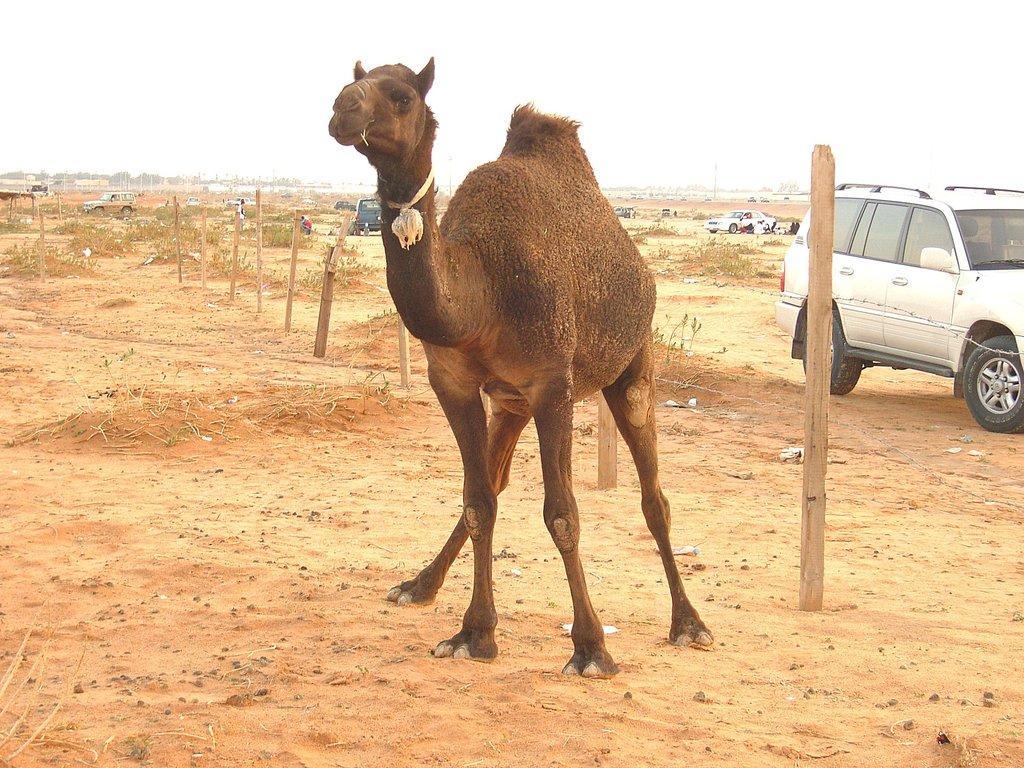Could you give a brief overview of what you see in this image? In this image there is a camel standing on the land. Behind it there are few wooden trunks on the land. There are few vehicles and few persons are on the land. Top of image there is sky. Left side there are few trees. 